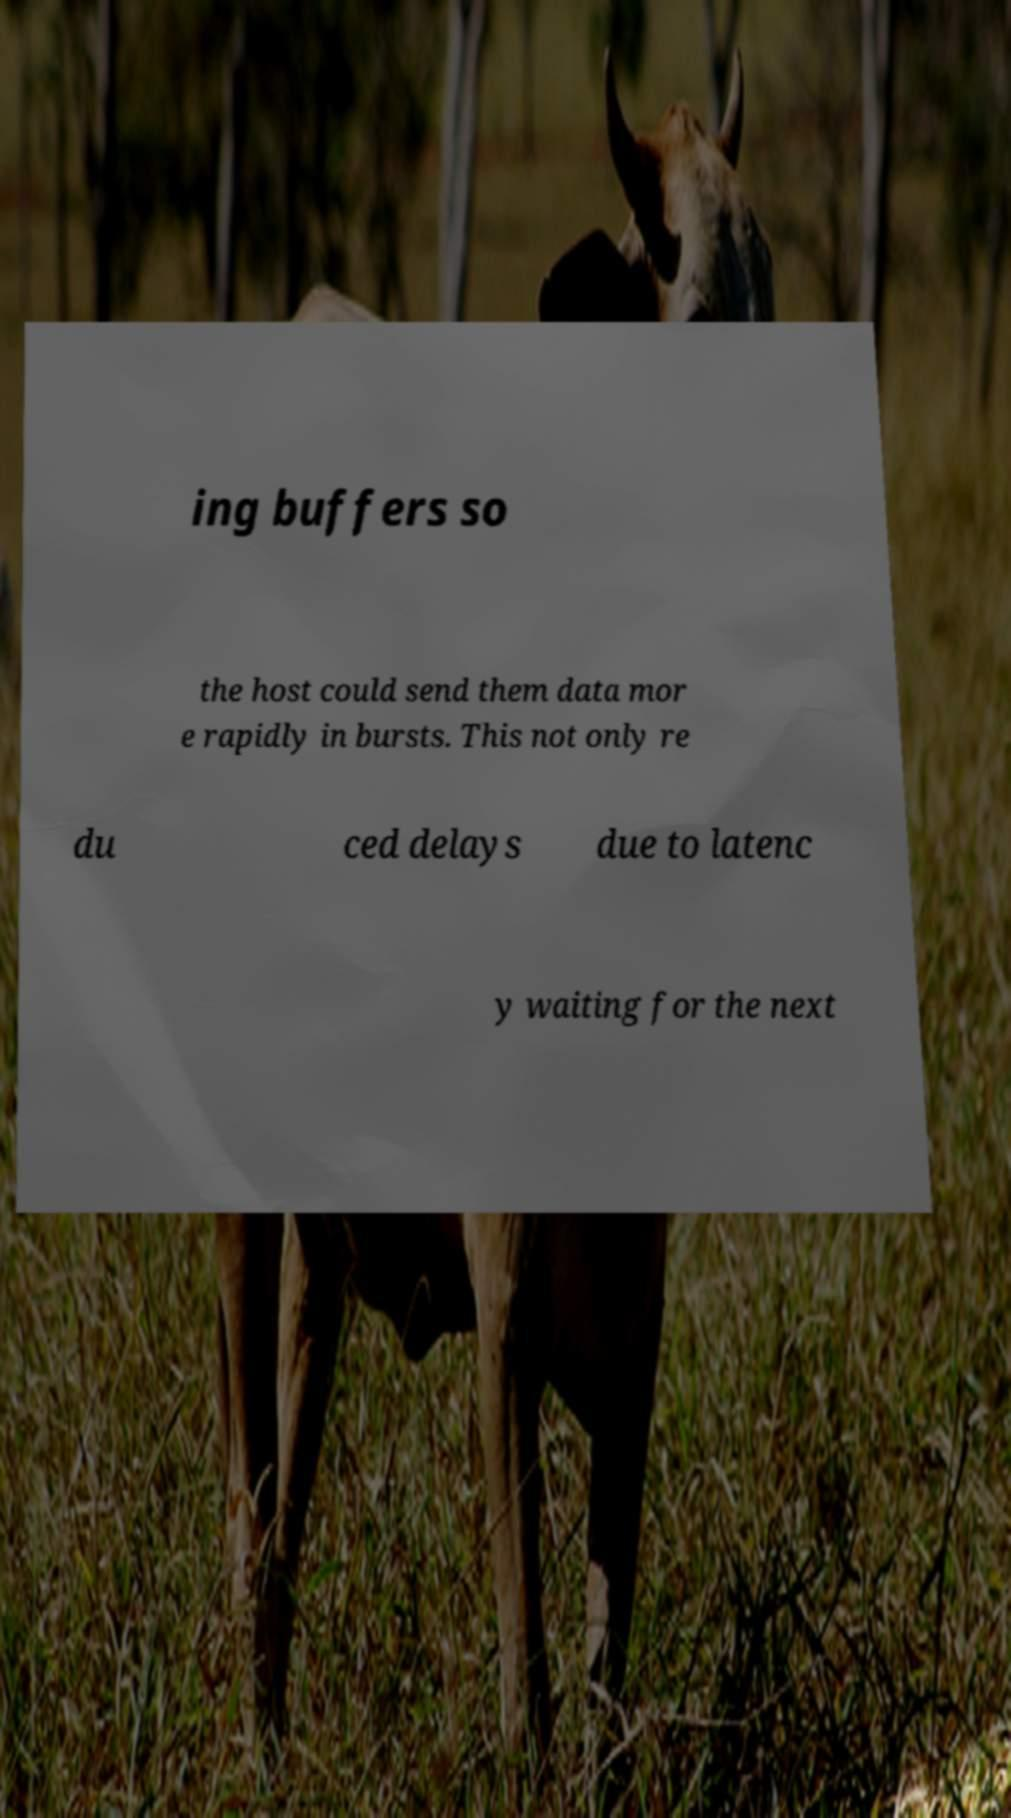What messages or text are displayed in this image? I need them in a readable, typed format. ing buffers so the host could send them data mor e rapidly in bursts. This not only re du ced delays due to latenc y waiting for the next 